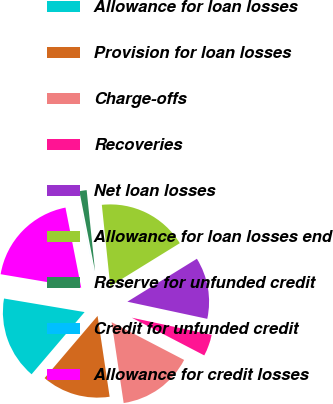<chart> <loc_0><loc_0><loc_500><loc_500><pie_chart><fcel>Allowance for loan losses<fcel>Provision for loan losses<fcel>Charge-offs<fcel>Recoveries<fcel>Net loan losses<fcel>Allowance for loan losses end<fcel>Reserve for unfunded credit<fcel>Credit for unfunded credit<fcel>Allowance for credit losses<nl><fcel>16.42%<fcel>13.59%<fcel>15.01%<fcel>4.27%<fcel>12.17%<fcel>17.84%<fcel>1.43%<fcel>0.01%<fcel>19.26%<nl></chart> 